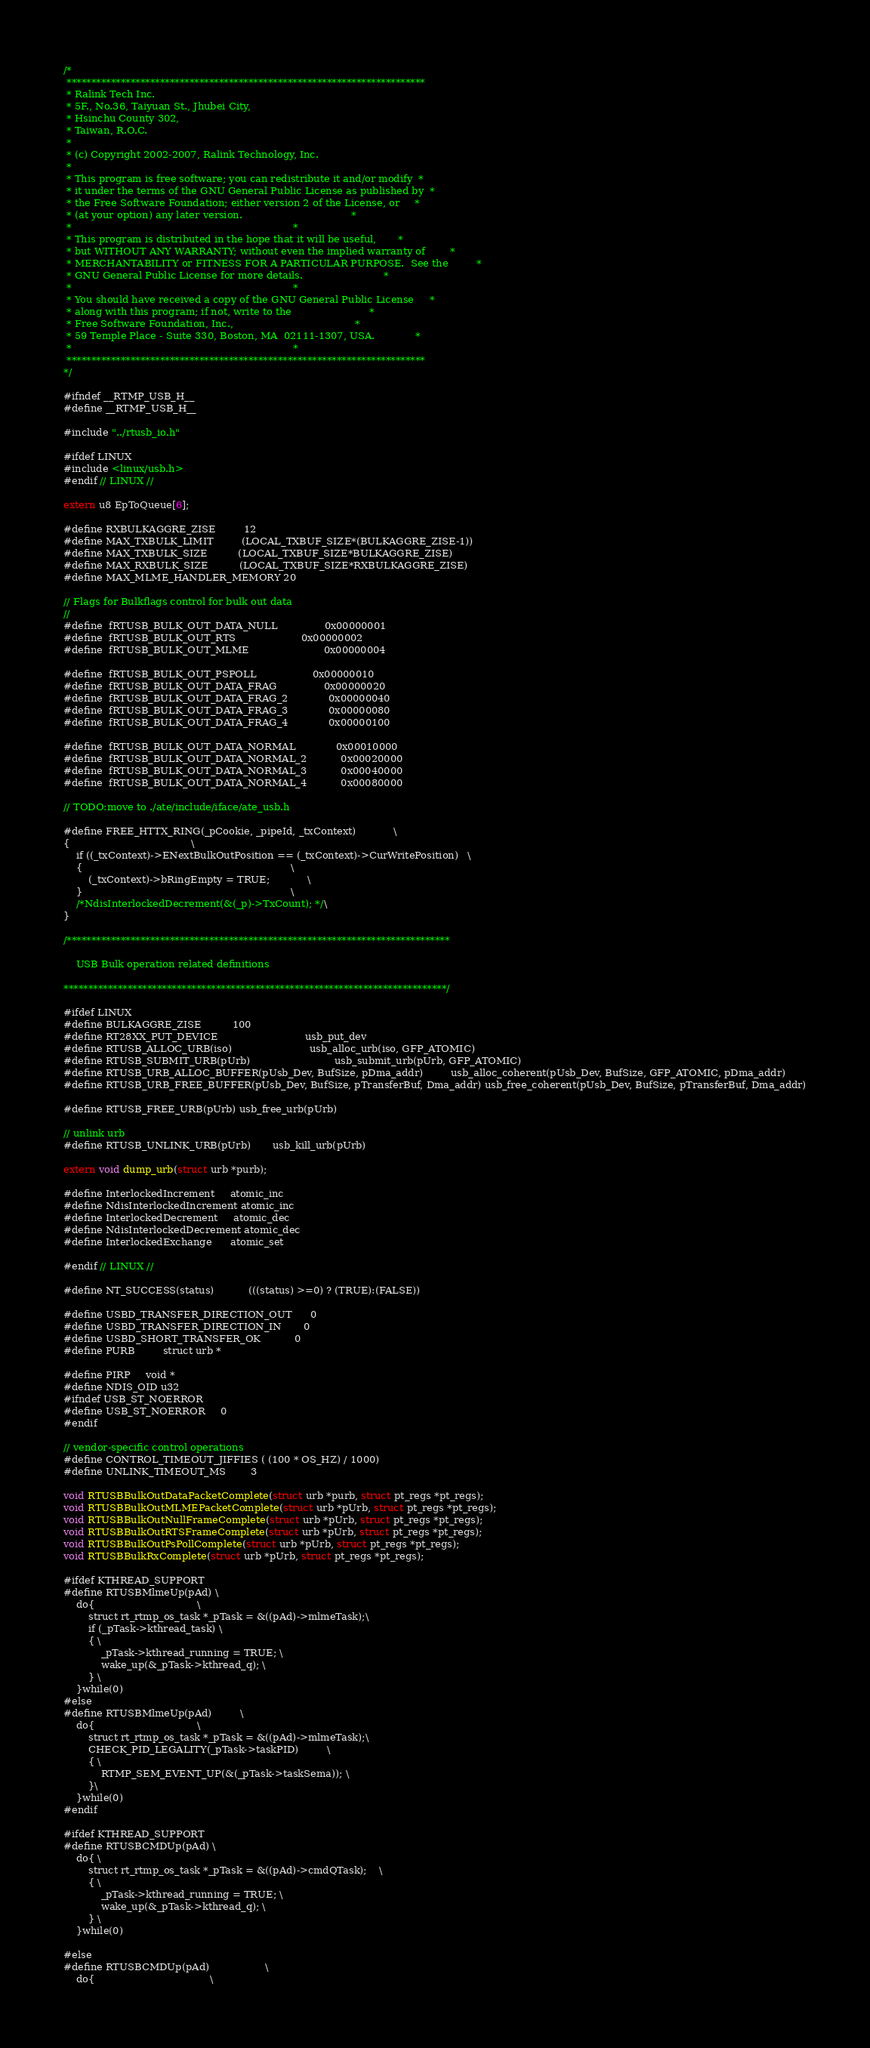Convert code to text. <code><loc_0><loc_0><loc_500><loc_500><_C_>/*
 *************************************************************************
 * Ralink Tech Inc.
 * 5F., No.36, Taiyuan St., Jhubei City,
 * Hsinchu County 302,
 * Taiwan, R.O.C.
 *
 * (c) Copyright 2002-2007, Ralink Technology, Inc.
 *
 * This program is free software; you can redistribute it and/or modify  *
 * it under the terms of the GNU General Public License as published by  *
 * the Free Software Foundation; either version 2 of the License, or     *
 * (at your option) any later version.                                   *
 *                                                                       *
 * This program is distributed in the hope that it will be useful,       *
 * but WITHOUT ANY WARRANTY; without even the implied warranty of        *
 * MERCHANTABILITY or FITNESS FOR A PARTICULAR PURPOSE.  See the         *
 * GNU General Public License for more details.                          *
 *                                                                       *
 * You should have received a copy of the GNU General Public License     *
 * along with this program; if not, write to the                         *
 * Free Software Foundation, Inc.,                                       *
 * 59 Temple Place - Suite 330, Boston, MA  02111-1307, USA.             *
 *                                                                       *
 *************************************************************************
*/

#ifndef __RTMP_USB_H__
#define __RTMP_USB_H__

#include "../rtusb_io.h"

#ifdef LINUX
#include <linux/usb.h>
#endif // LINUX //

extern u8 EpToQueue[6];

#define RXBULKAGGRE_ZISE			12
#define MAX_TXBULK_LIMIT			(LOCAL_TXBUF_SIZE*(BULKAGGRE_ZISE-1))
#define MAX_TXBULK_SIZE			(LOCAL_TXBUF_SIZE*BULKAGGRE_ZISE)
#define MAX_RXBULK_SIZE			(LOCAL_TXBUF_SIZE*RXBULKAGGRE_ZISE)
#define MAX_MLME_HANDLER_MEMORY 20

// Flags for Bulkflags control for bulk out data
//
#define	fRTUSB_BULK_OUT_DATA_NULL				0x00000001
#define	fRTUSB_BULK_OUT_RTS						0x00000002
#define	fRTUSB_BULK_OUT_MLME						0x00000004

#define	fRTUSB_BULK_OUT_PSPOLL					0x00000010
#define	fRTUSB_BULK_OUT_DATA_FRAG				0x00000020
#define	fRTUSB_BULK_OUT_DATA_FRAG_2				0x00000040
#define	fRTUSB_BULK_OUT_DATA_FRAG_3				0x00000080
#define	fRTUSB_BULK_OUT_DATA_FRAG_4				0x00000100

#define	fRTUSB_BULK_OUT_DATA_NORMAL				0x00010000
#define	fRTUSB_BULK_OUT_DATA_NORMAL_2			0x00020000
#define	fRTUSB_BULK_OUT_DATA_NORMAL_3			0x00040000
#define	fRTUSB_BULK_OUT_DATA_NORMAL_4			0x00080000

// TODO:move to ./ate/include/iface/ate_usb.h

#define FREE_HTTX_RING(_pCookie, _pipeId, _txContext)			\
{										\
	if ((_txContext)->ENextBulkOutPosition == (_txContext)->CurWritePosition)	\
	{																	\
		(_txContext)->bRingEmpty = TRUE;			\
	}																	\
	/*NdisInterlockedDecrement(&(_p)->TxCount); */\
}

/******************************************************************************

	USB Bulk operation related definitions

******************************************************************************/

#ifdef LINUX
#define BULKAGGRE_ZISE          100
#define RT28XX_PUT_DEVICE							usb_put_dev
#define RTUSB_ALLOC_URB(iso)							usb_alloc_urb(iso, GFP_ATOMIC)
#define RTUSB_SUBMIT_URB(pUrb)							usb_submit_urb(pUrb, GFP_ATOMIC)
#define RTUSB_URB_ALLOC_BUFFER(pUsb_Dev, BufSize, pDma_addr)			usb_alloc_coherent(pUsb_Dev, BufSize, GFP_ATOMIC, pDma_addr)
#define RTUSB_URB_FREE_BUFFER(pUsb_Dev, BufSize, pTransferBuf, Dma_addr)	usb_free_coherent(pUsb_Dev, BufSize, pTransferBuf, Dma_addr)

#define RTUSB_FREE_URB(pUrb)	usb_free_urb(pUrb)

// unlink urb
#define RTUSB_UNLINK_URB(pUrb)		usb_kill_urb(pUrb)

extern void dump_urb(struct urb *purb);

#define InterlockedIncrement		atomic_inc
#define NdisInterlockedIncrement	atomic_inc
#define InterlockedDecrement		atomic_dec
#define NdisInterlockedDecrement	atomic_dec
#define InterlockedExchange		atomic_set

#endif // LINUX //

#define NT_SUCCESS(status)			(((status) >=0) ? (TRUE):(FALSE))

#define USBD_TRANSFER_DIRECTION_OUT		0
#define USBD_TRANSFER_DIRECTION_IN		0
#define USBD_SHORT_TRANSFER_OK			0
#define PURB			struct urb *

#define PIRP		void *
#define NDIS_OID	u32
#ifndef USB_ST_NOERROR
#define USB_ST_NOERROR     0
#endif

// vendor-specific control operations
#define CONTROL_TIMEOUT_JIFFIES ( (100 * OS_HZ) / 1000)
#define UNLINK_TIMEOUT_MS		3

void RTUSBBulkOutDataPacketComplete(struct urb *purb, struct pt_regs *pt_regs);
void RTUSBBulkOutMLMEPacketComplete(struct urb *pUrb, struct pt_regs *pt_regs);
void RTUSBBulkOutNullFrameComplete(struct urb *pUrb, struct pt_regs *pt_regs);
void RTUSBBulkOutRTSFrameComplete(struct urb *pUrb, struct pt_regs *pt_regs);
void RTUSBBulkOutPsPollComplete(struct urb *pUrb, struct pt_regs *pt_regs);
void RTUSBBulkRxComplete(struct urb *pUrb, struct pt_regs *pt_regs);

#ifdef KTHREAD_SUPPORT
#define RTUSBMlmeUp(pAd) \
	do{								    \
		struct rt_rtmp_os_task *_pTask = &((pAd)->mlmeTask);\
		if (_pTask->kthread_task) \
        { \
			_pTask->kthread_running = TRUE; \
	        wake_up(&_pTask->kthread_q); \
		} \
	}while(0)
#else
#define RTUSBMlmeUp(pAd)	        \
	do{								    \
		struct rt_rtmp_os_task *_pTask = &((pAd)->mlmeTask);\
		CHECK_PID_LEGALITY(_pTask->taskPID)		    \
		{ \
			RTMP_SEM_EVENT_UP(&(_pTask->taskSema)); \
		}\
	}while(0)
#endif

#ifdef KTHREAD_SUPPORT
#define RTUSBCMDUp(pAd) \
	do{	\
		struct rt_rtmp_os_task *_pTask = &((pAd)->cmdQTask);	\
		{ \
			_pTask->kthread_running = TRUE; \
	        wake_up(&_pTask->kthread_q); \
		} \
	}while(0)

#else
#define RTUSBCMDUp(pAd)	                \
	do{									    \</code> 